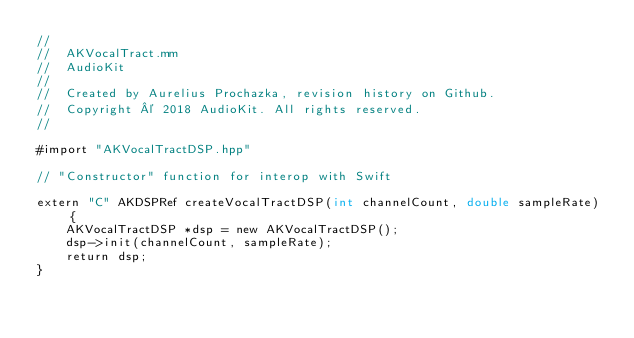<code> <loc_0><loc_0><loc_500><loc_500><_ObjectiveC_>//
//  AKVocalTract.mm
//  AudioKit
//
//  Created by Aurelius Prochazka, revision history on Github.
//  Copyright © 2018 AudioKit. All rights reserved.
//

#import "AKVocalTractDSP.hpp"

// "Constructor" function for interop with Swift

extern "C" AKDSPRef createVocalTractDSP(int channelCount, double sampleRate) {
    AKVocalTractDSP *dsp = new AKVocalTractDSP();
    dsp->init(channelCount, sampleRate);
    return dsp;
}
</code> 